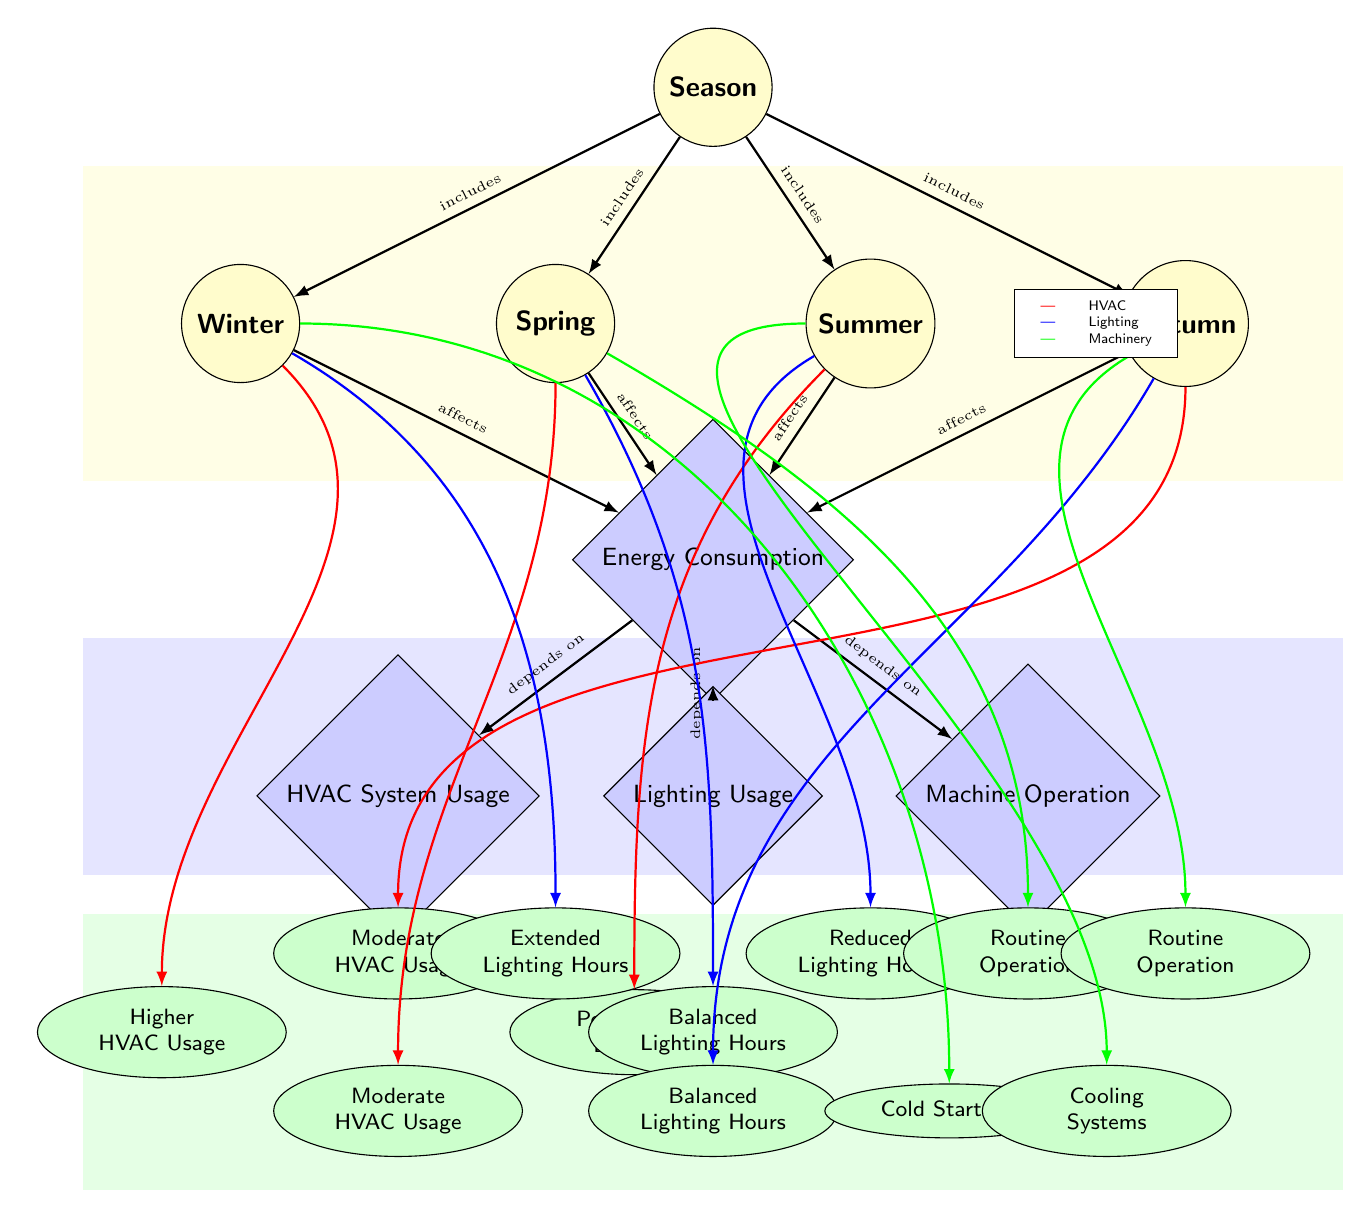What are the four seasons represented in the diagram? The diagram includes the nodes labeled as Winter, Spring, Summer, and Autumn. These nodes clearly illustrate the four distinct seasons.
Answer: Winter, Spring, Summer, Autumn Which factor is connected to the "Peak HVAC Demand"? The "Peak HVAC Demand" is connected to the Summer season node. This connection is represented by an arrow indicating the specific seasonal influence on HVAC usage.
Answer: Summer How many factors affect energy consumption? The diagram shows three factors affecting energy consumption: HVAC System Usage, Lighting Usage, and Machine Operation, indicated by the nodes connected to the Energy Consumption node.
Answer: 3 What is the usage pattern associated with Winter regarding lighting? The diagram indicates that the usage pattern associated with Winter for lighting is represented by the node labeled "Extended Lighting Hours." This connection is made through an arrow linked to the Winter season node.
Answer: Extended Lighting Hours What seasonal pattern leads to "Cooling Systems" usage? The usage of "Cooling Systems" corresponds to the Summer season, as depicted by the arrow pointing from the Summer node to the Cooling Systems node, indicating that this pattern increases during that season.
Answer: Summer 